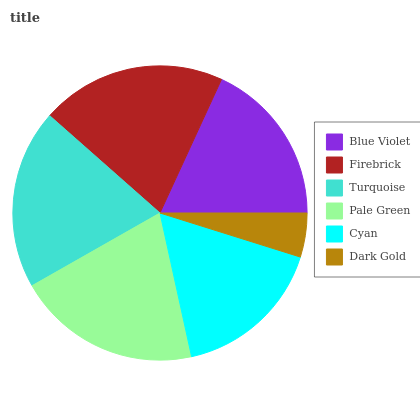Is Dark Gold the minimum?
Answer yes or no. Yes. Is Firebrick the maximum?
Answer yes or no. Yes. Is Turquoise the minimum?
Answer yes or no. No. Is Turquoise the maximum?
Answer yes or no. No. Is Firebrick greater than Turquoise?
Answer yes or no. Yes. Is Turquoise less than Firebrick?
Answer yes or no. Yes. Is Turquoise greater than Firebrick?
Answer yes or no. No. Is Firebrick less than Turquoise?
Answer yes or no. No. Is Turquoise the high median?
Answer yes or no. Yes. Is Blue Violet the low median?
Answer yes or no. Yes. Is Dark Gold the high median?
Answer yes or no. No. Is Turquoise the low median?
Answer yes or no. No. 